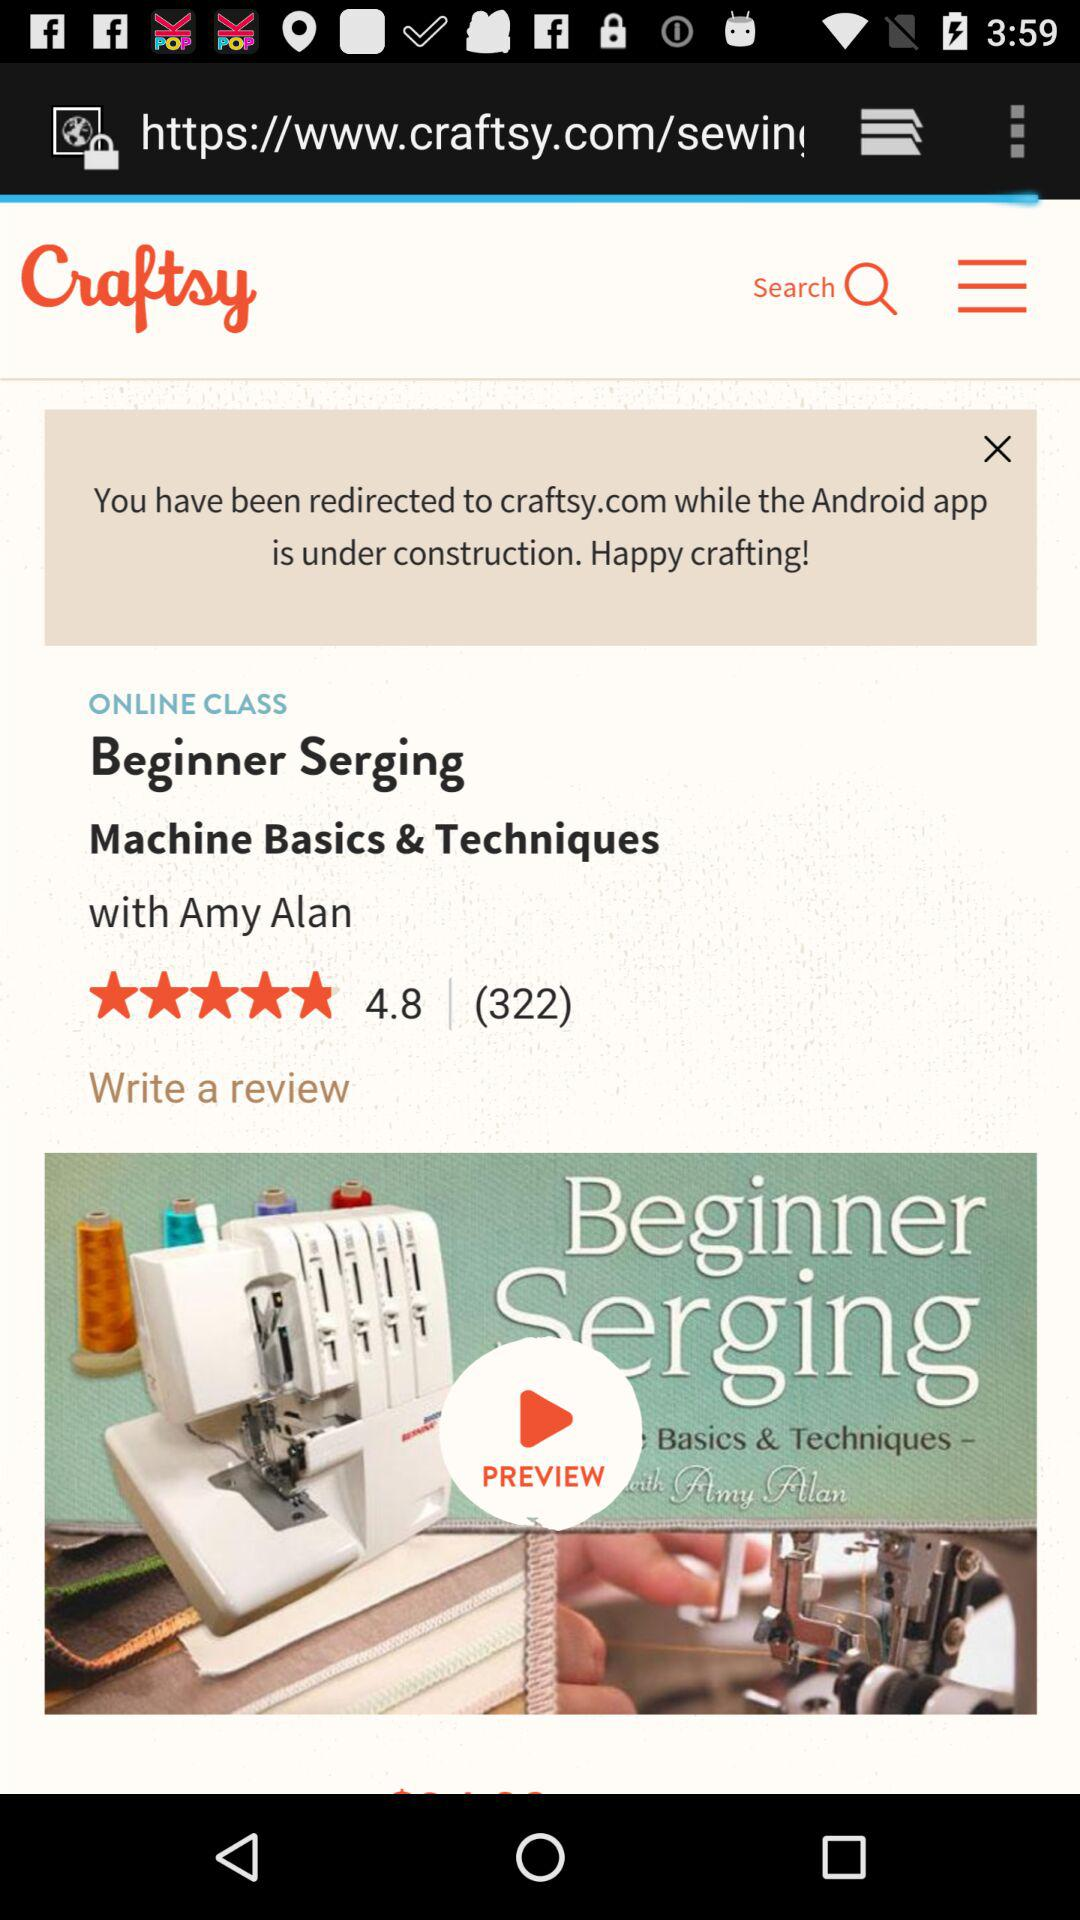What is the app name? The app name is "Craftsy". 